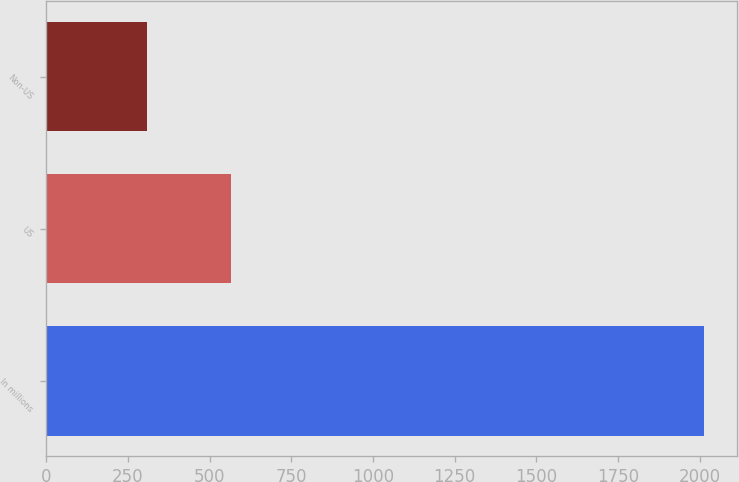<chart> <loc_0><loc_0><loc_500><loc_500><bar_chart><fcel>In millions<fcel>US<fcel>Non-US<nl><fcel>2014<fcel>565<fcel>307<nl></chart> 